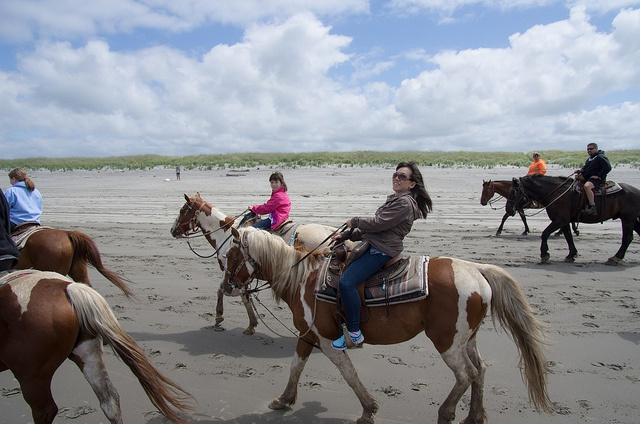Describe the objects in this image and their specific colors. I can see horse in darkgray, black, and gray tones, horse in darkgray, black, gray, and maroon tones, people in darkgray, black, and gray tones, horse in darkgray, black, and gray tones, and horse in darkgray, black, gray, and lightgray tones in this image. 